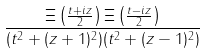<formula> <loc_0><loc_0><loc_500><loc_500>\frac { \Xi \left ( \frac { t + i z } { 2 } \right ) \Xi \left ( \frac { t - i z } { 2 } \right ) } { ( t ^ { 2 } + ( z + 1 ) ^ { 2 } ) ( t ^ { 2 } + ( z - 1 ) ^ { 2 } ) }</formula> 